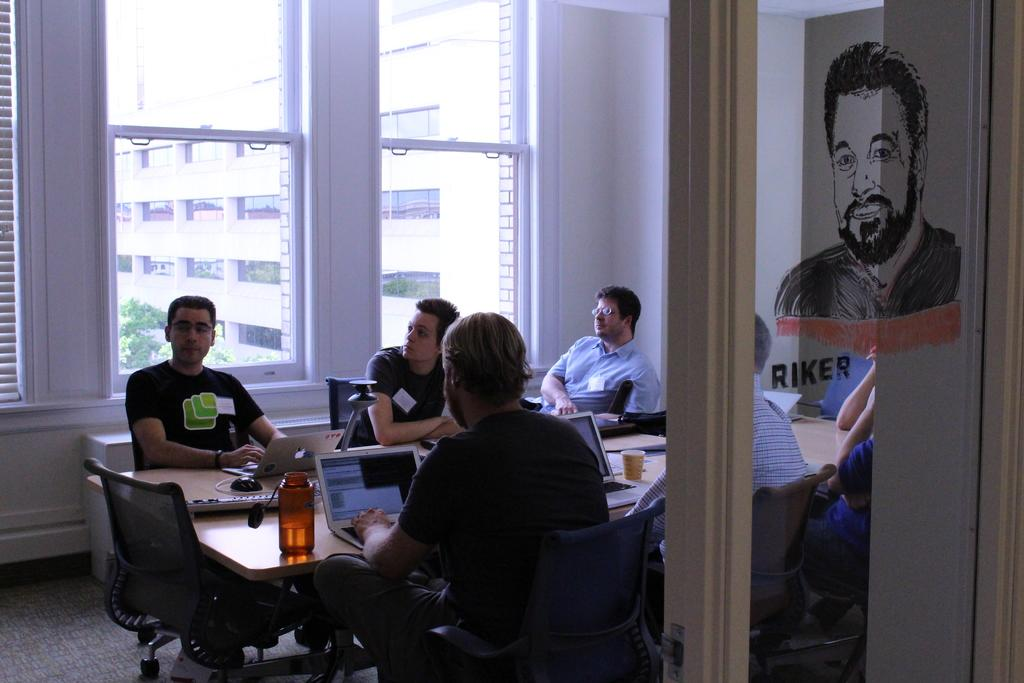How many people are in the image? There is a group of people in the image. What are the people doing in the image? The people are sitting in chairs. What is on the table in the image? There is a cup, a laptop, a mouse, a keyboard, and a bottle on the table. What can be seen in the background of the image? There is a building, a tree, and a window in the background of the image. What type of adjustment is the fly making to the laptop in the image? There is no fly present in the image, so no adjustment can be made by a fly. 